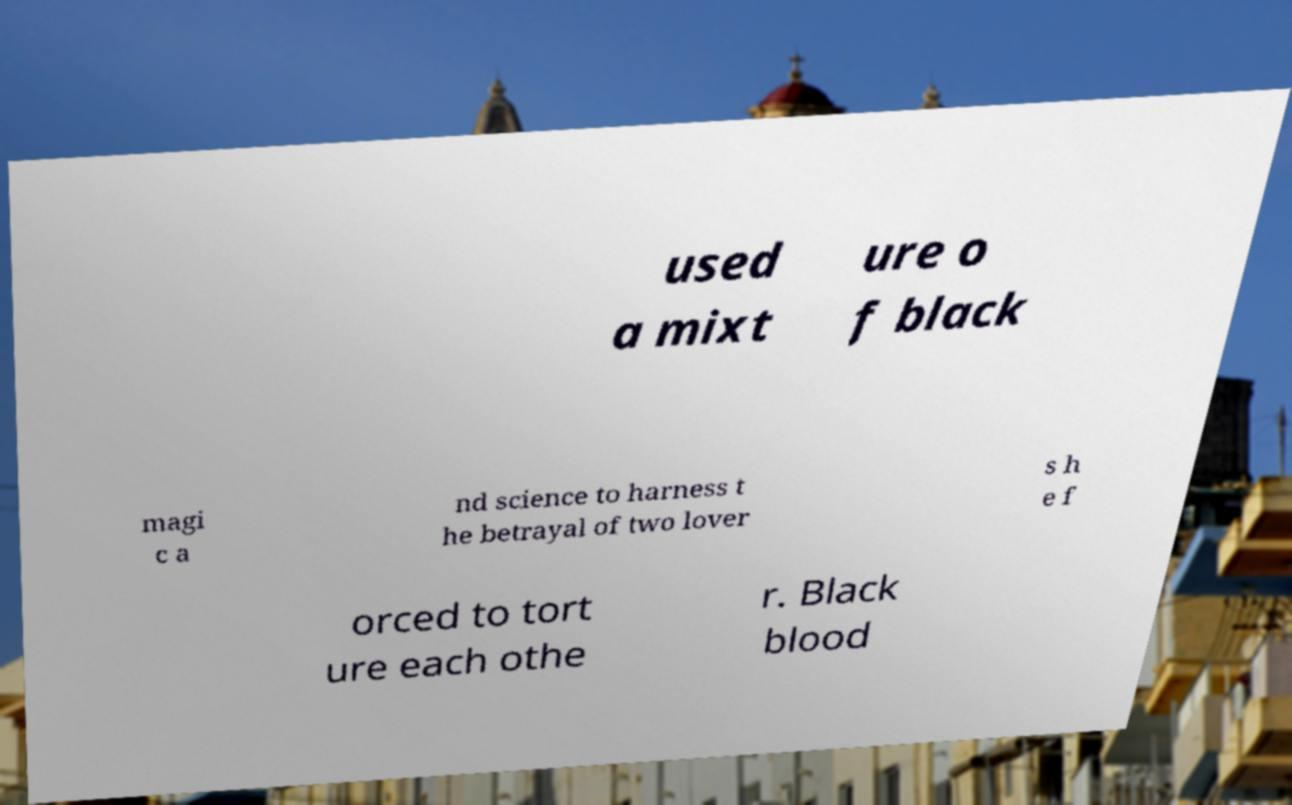Could you extract and type out the text from this image? used a mixt ure o f black magi c a nd science to harness t he betrayal of two lover s h e f orced to tort ure each othe r. Black blood 